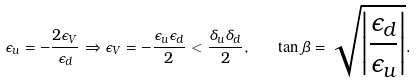<formula> <loc_0><loc_0><loc_500><loc_500>\epsilon _ { u } = - \frac { 2 \epsilon _ { V } } { \epsilon _ { d } } \Rightarrow \epsilon _ { V } = - \frac { \epsilon _ { u } \epsilon _ { d } } { 2 } < \frac { \delta _ { u } \delta _ { d } } { 2 } , \quad \tan \beta = \sqrt { \left | \frac { \epsilon _ { d } } { \epsilon _ { u } } \right | } .</formula> 